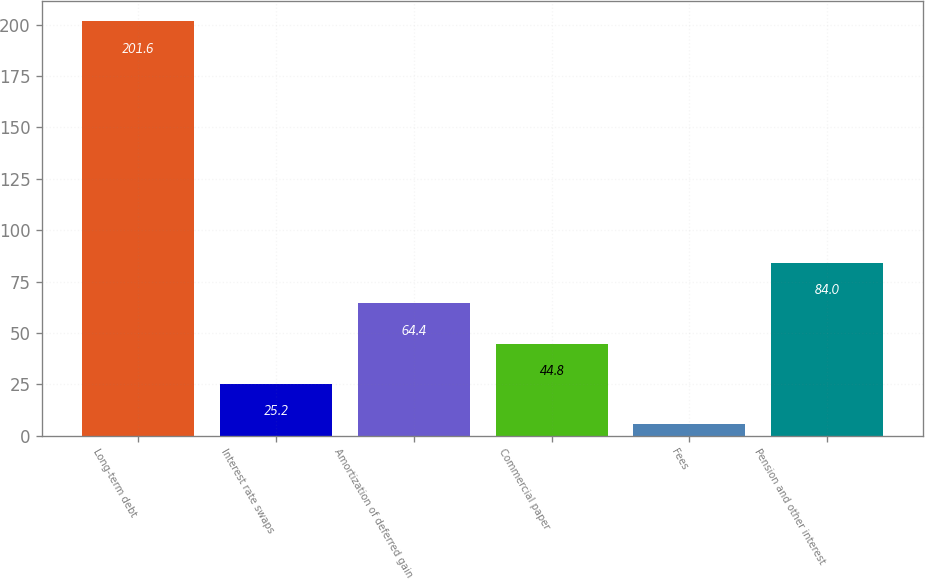<chart> <loc_0><loc_0><loc_500><loc_500><bar_chart><fcel>Long-term debt<fcel>Interest rate swaps<fcel>Amortization of deferred gain<fcel>Commercial paper<fcel>Fees<fcel>Pension and other interest<nl><fcel>201.6<fcel>25.2<fcel>64.4<fcel>44.8<fcel>5.6<fcel>84<nl></chart> 